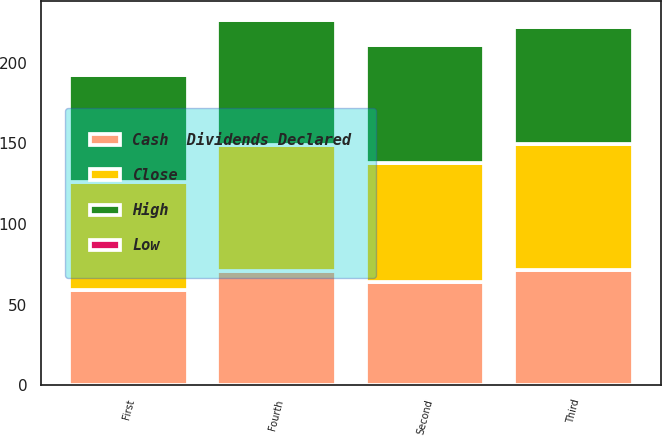Convert chart to OTSL. <chart><loc_0><loc_0><loc_500><loc_500><stacked_bar_chart><ecel><fcel>First<fcel>Second<fcel>Third<fcel>Fourth<nl><fcel>Close<fcel>66.93<fcel>74.19<fcel>77.93<fcel>78.36<nl><fcel>Cash  Dividends Declared<fcel>58.96<fcel>63.69<fcel>71.48<fcel>70.63<nl><fcel>High<fcel>66.5<fcel>72.92<fcel>72.45<fcel>77.58<nl><fcel>Low<fcel>0.4<fcel>0.44<fcel>0.44<fcel>0.44<nl></chart> 